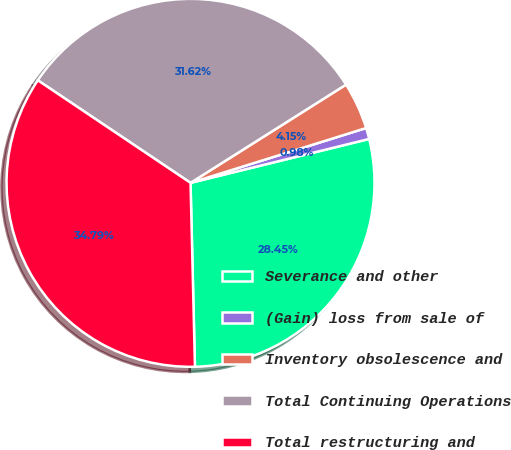Convert chart to OTSL. <chart><loc_0><loc_0><loc_500><loc_500><pie_chart><fcel>Severance and other<fcel>(Gain) loss from sale of<fcel>Inventory obsolescence and<fcel>Total Continuing Operations<fcel>Total restructuring and<nl><fcel>28.45%<fcel>0.98%<fcel>4.15%<fcel>31.62%<fcel>34.79%<nl></chart> 